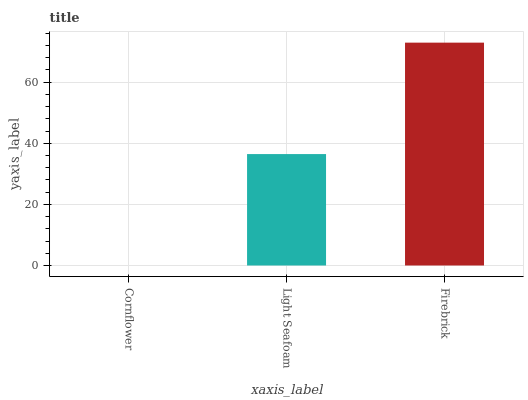Is Cornflower the minimum?
Answer yes or no. Yes. Is Firebrick the maximum?
Answer yes or no. Yes. Is Light Seafoam the minimum?
Answer yes or no. No. Is Light Seafoam the maximum?
Answer yes or no. No. Is Light Seafoam greater than Cornflower?
Answer yes or no. Yes. Is Cornflower less than Light Seafoam?
Answer yes or no. Yes. Is Cornflower greater than Light Seafoam?
Answer yes or no. No. Is Light Seafoam less than Cornflower?
Answer yes or no. No. Is Light Seafoam the high median?
Answer yes or no. Yes. Is Light Seafoam the low median?
Answer yes or no. Yes. Is Firebrick the high median?
Answer yes or no. No. Is Cornflower the low median?
Answer yes or no. No. 